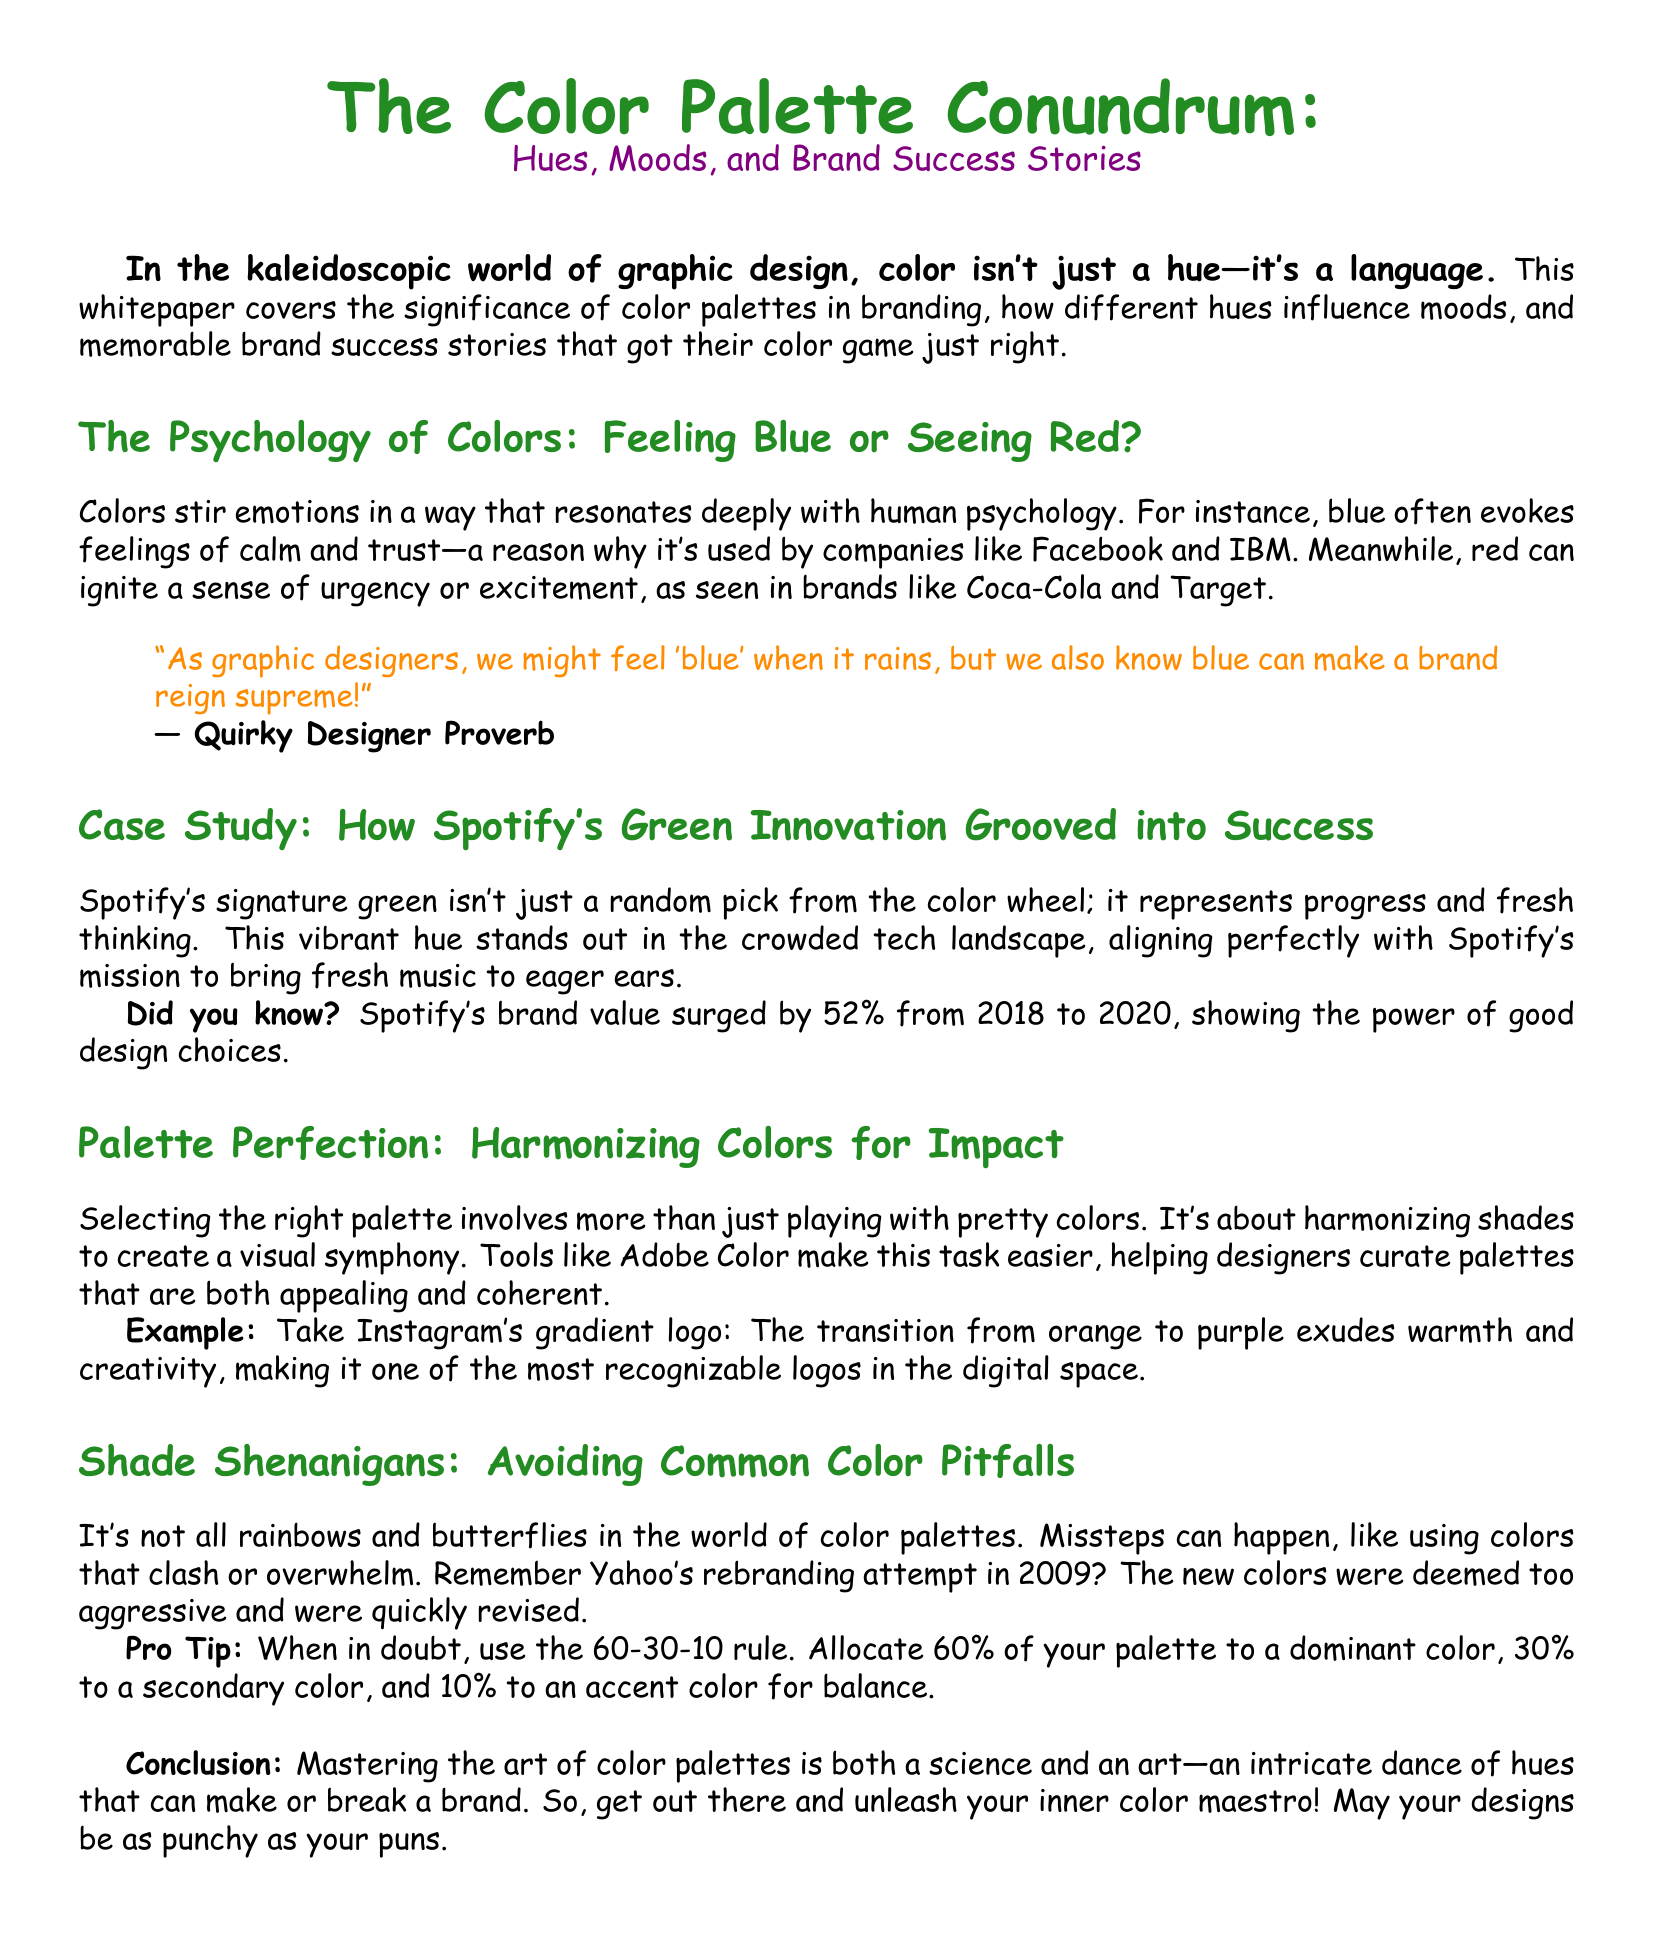What does blue evoke? The document states that blue often evokes feelings of calm and trust.
Answer: Calm and trust What color represents Spotify? The whitepaper mentions that Spotify's signature green represents progress and fresh thinking.
Answer: Green What percentage did Spotify's brand value surge from 2018 to 2020? The document specifies that Spotify's brand value surged by 52%.
Answer: 52% What rule is suggested for color allocation? The document suggests the 60-30-10 rule for color allocation.
Answer: 60-30-10 rule What was the consequence of Yahoo's 2009 rebranding? The document states that the new colors were deemed too aggressive and were quickly revised.
Answer: Quickly revised What type of document is this? The format and content indicate that this is a whitepaper.
Answer: Whitepaper What tool is mentioned for curating color palettes? The document refers to Adobe Color as a tool for curating palettes.
Answer: Adobe Color What color transition does Instagram's logo use? The document describes the transition from orange to purple in Instagram's logo.
Answer: Orange to purple 